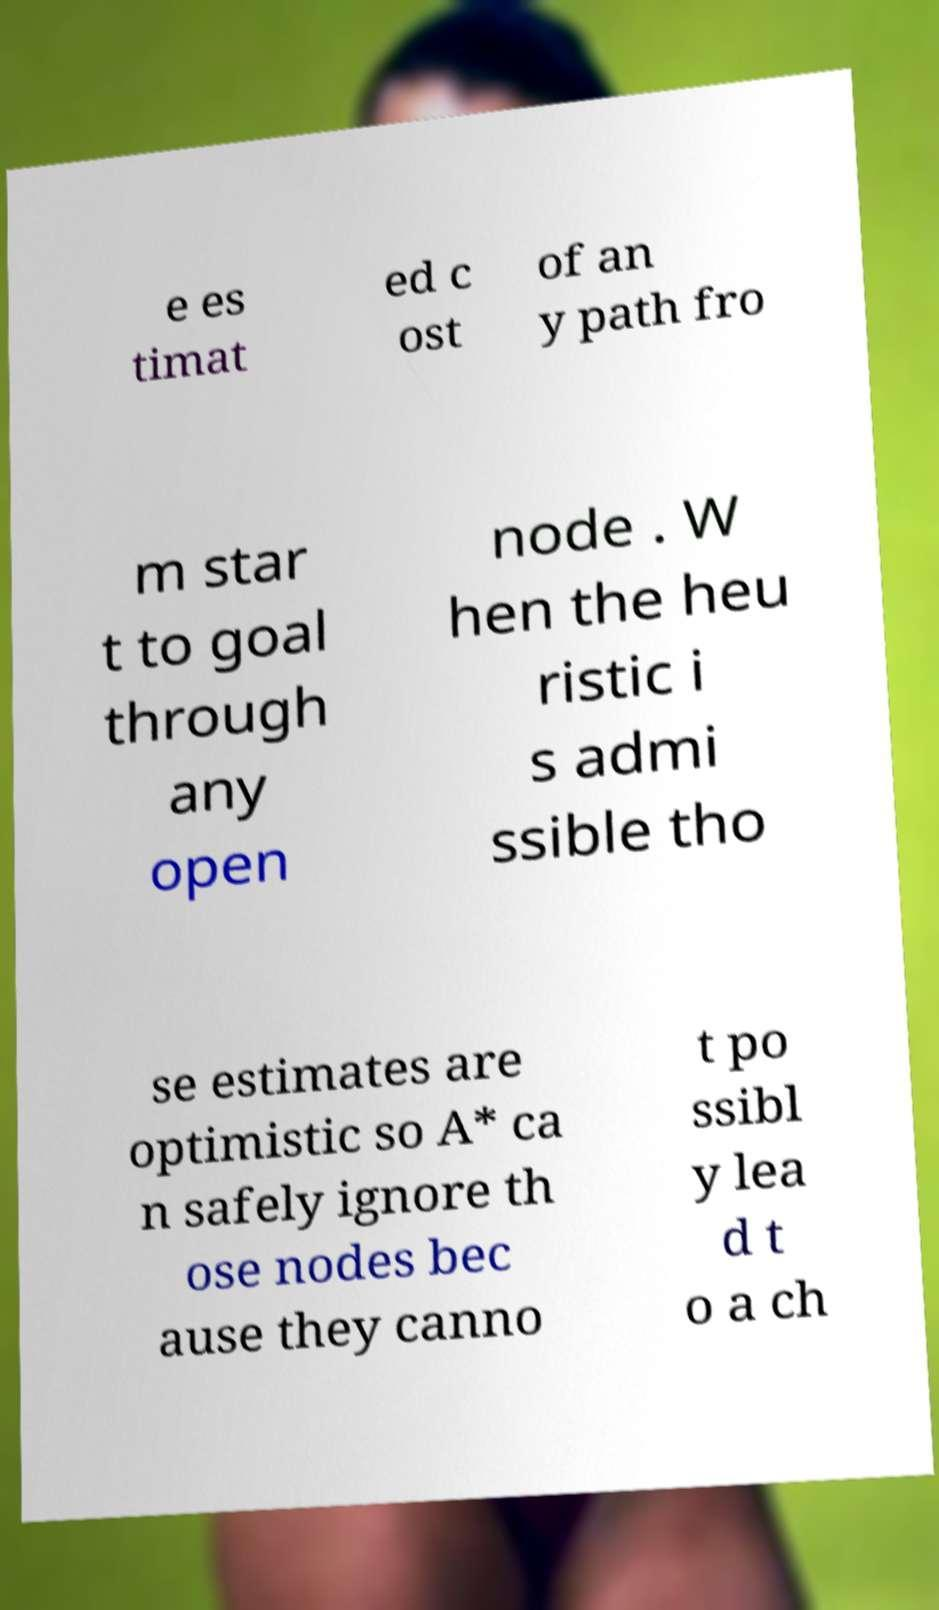I need the written content from this picture converted into text. Can you do that? e es timat ed c ost of an y path fro m star t to goal through any open node . W hen the heu ristic i s admi ssible tho se estimates are optimistic so A* ca n safely ignore th ose nodes bec ause they canno t po ssibl y lea d t o a ch 